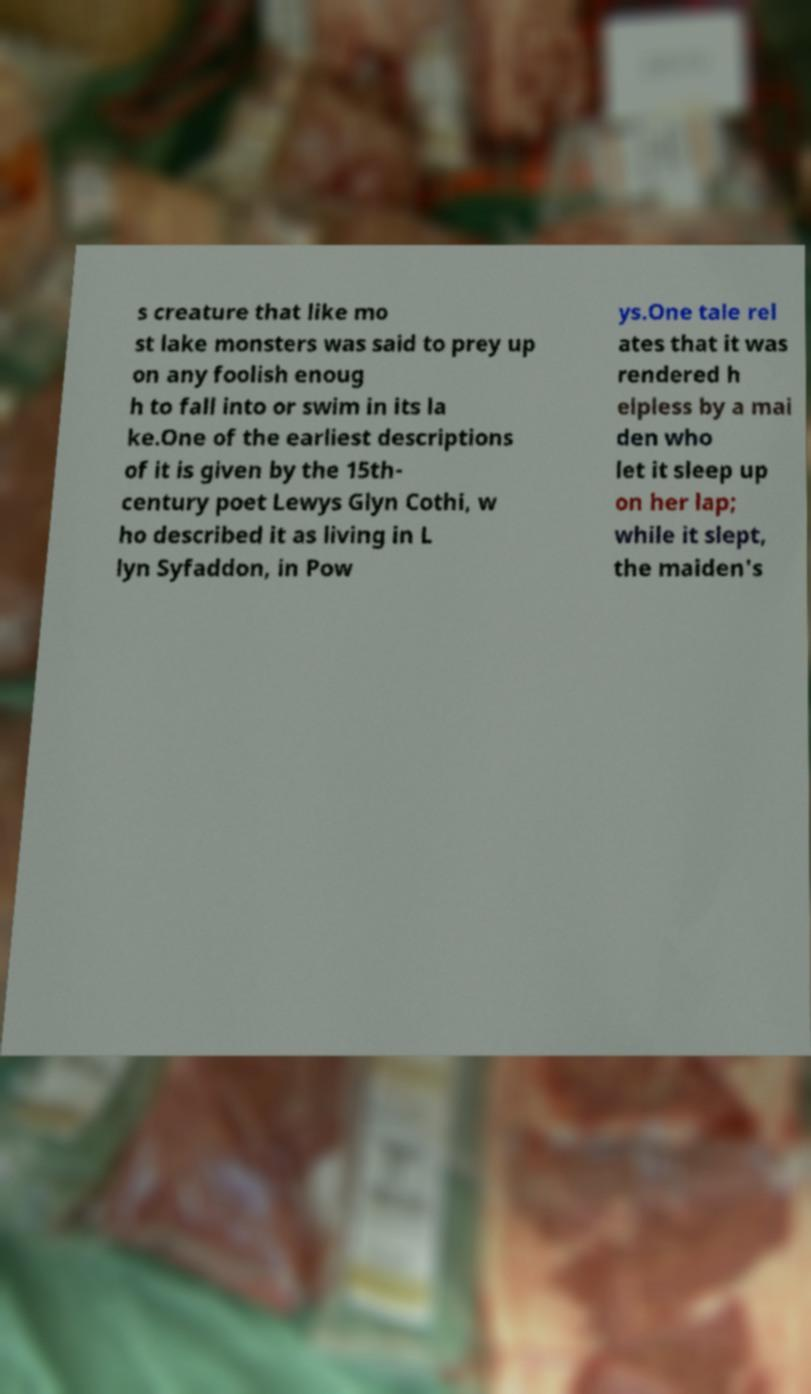Please read and relay the text visible in this image. What does it say? s creature that like mo st lake monsters was said to prey up on any foolish enoug h to fall into or swim in its la ke.One of the earliest descriptions of it is given by the 15th- century poet Lewys Glyn Cothi, w ho described it as living in L lyn Syfaddon, in Pow ys.One tale rel ates that it was rendered h elpless by a mai den who let it sleep up on her lap; while it slept, the maiden's 